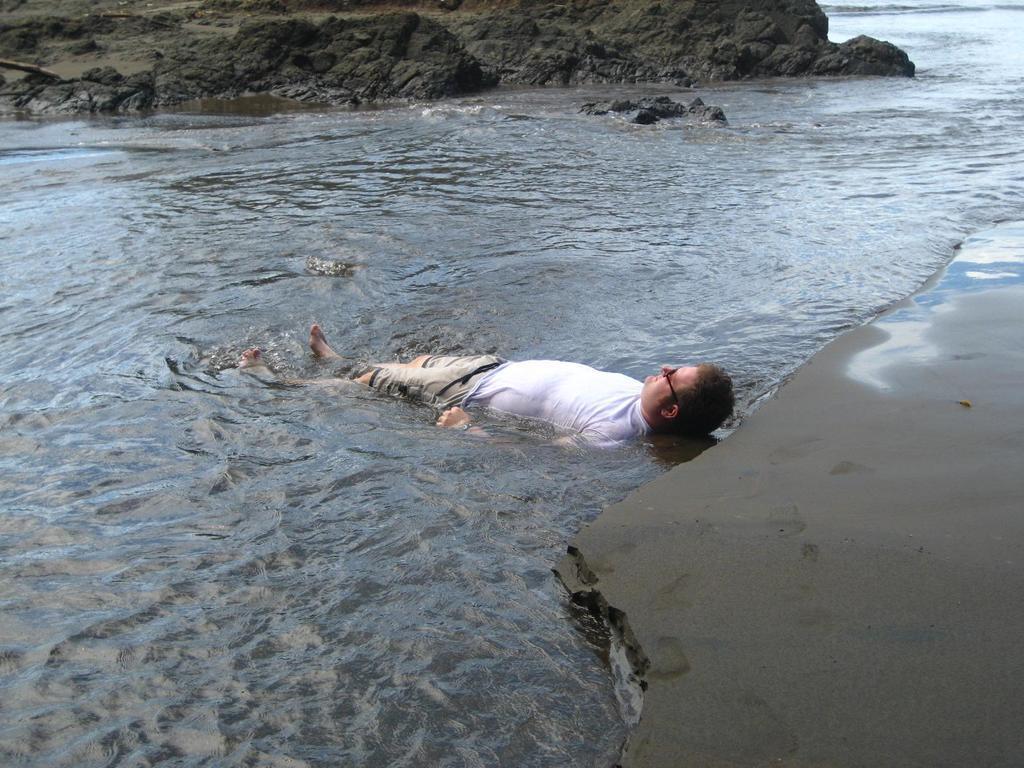Describe this image in one or two sentences. In the center of the image we can see person sleeping in the water. In the background we can see rocks and water. 